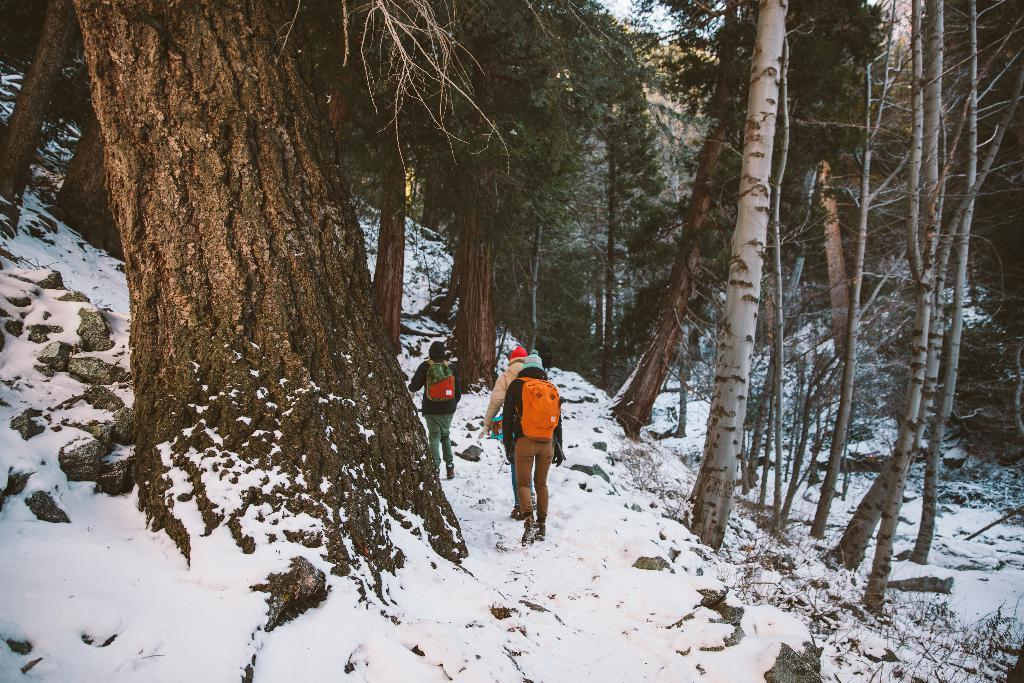How many people are in the snow in the image? There are three people in the snow in the image. What are two of the people wearing? Two of the people are wearing bags. What can be seen in the snow besides the people? There are stones visible in the snow. What is the direction of the trees in the image? The trees are visible from left to right in the image. What type of tools does the carpenter use in the image? There is no carpenter present in the image, so no tools can be observed. What is the cause of the loss experienced by the people in the image? There is no indication of loss experienced by the people in the image, as they are simply standing in the snow. 